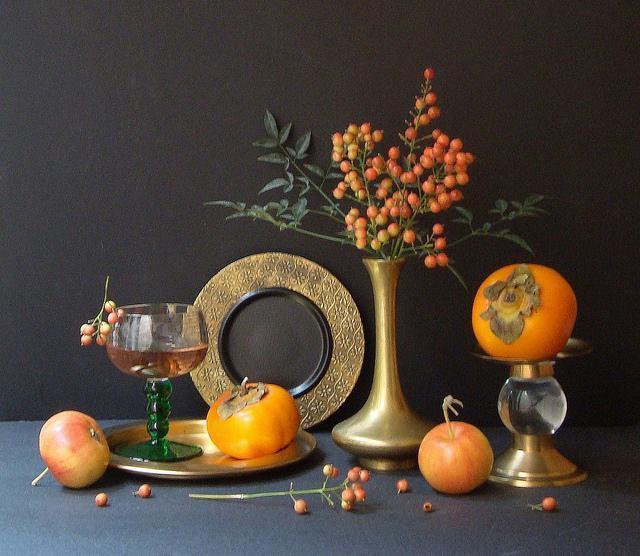How many apples are in the picture?
Give a very brief answer. 2. How many apples can you see?
Give a very brief answer. 2. How many oranges are there?
Give a very brief answer. 2. 